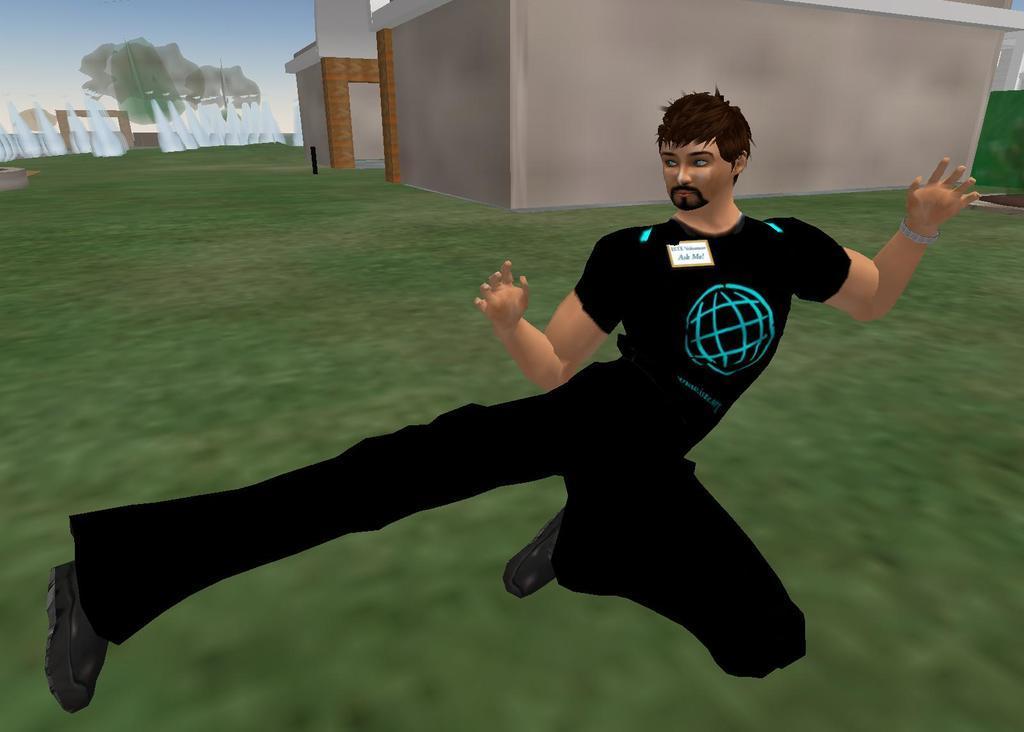Could you give a brief overview of what you see in this image? This is an animated picture. In the foreground of the picture there is a person in black dress. In the center of the picture there are buildings. On the left there are some objects in white color. 